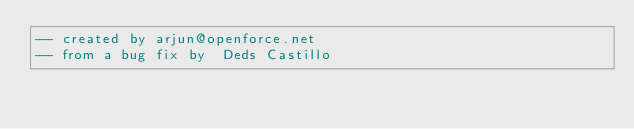<code> <loc_0><loc_0><loc_500><loc_500><_SQL_>-- created by arjun@openforce.net 
-- from a bug fix by  Deds Castillo
</code> 